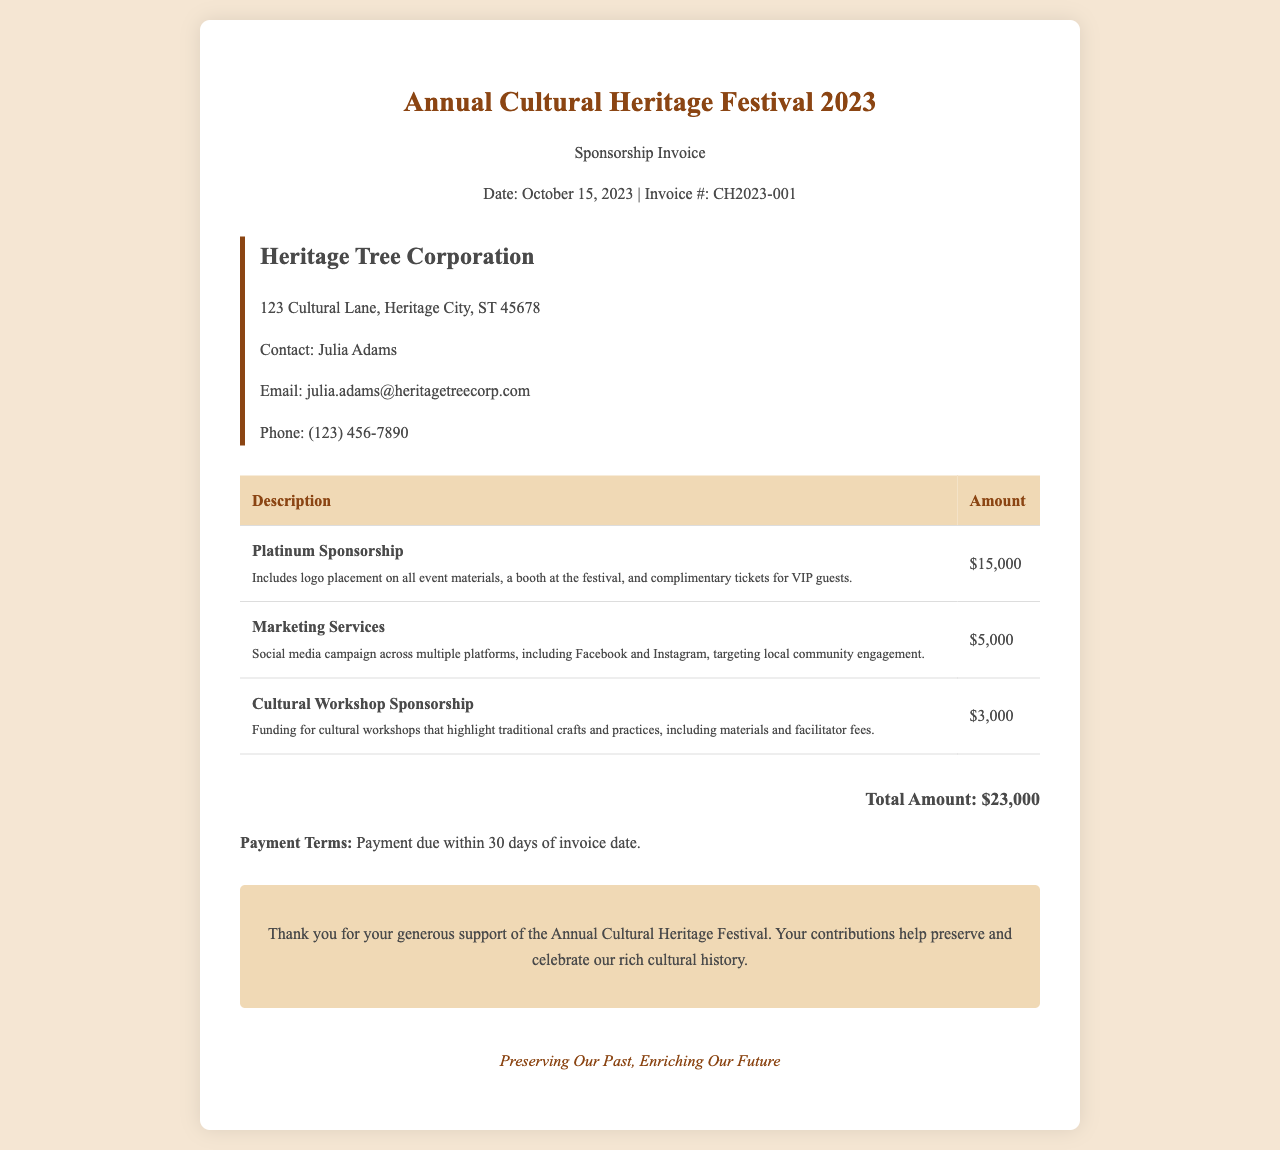What is the invoice date? The invoice date is specified as October 15, 2023.
Answer: October 15, 2023 Who is the contact person for Heritage Tree Corporation? The contact person listed in the document is Julia Adams.
Answer: Julia Adams What is the total amount due? The total amount due is mentioned at the bottom of the invoice as $23,000.
Answer: $23,000 What does the Platinum Sponsorship include? The document states that it includes logo placement on all event materials, a booth at the festival, and complimentary tickets for VIP guests.
Answer: Logo placement on all event materials, booth at the festival, and VIP tickets How much is allocated for Marketing Services? The invoice specifies that the amount allocated for Marketing Services is $5,000.
Answer: $5,000 What are the payment terms? The payment terms are clearly stated as payment due within 30 days of the invoice date.
Answer: Payment due within 30 days What is the purpose of the Cultural Workshop Sponsorship? According to the invoice, the sponsorship funds cultural workshops highlighting traditional crafts and practices.
Answer: Funding for cultural workshops What is the company address for Heritage Tree Corporation? The address provided in the document is 123 Cultural Lane, Heritage City, ST 45678.
Answer: 123 Cultural Lane, Heritage City, ST 45678 